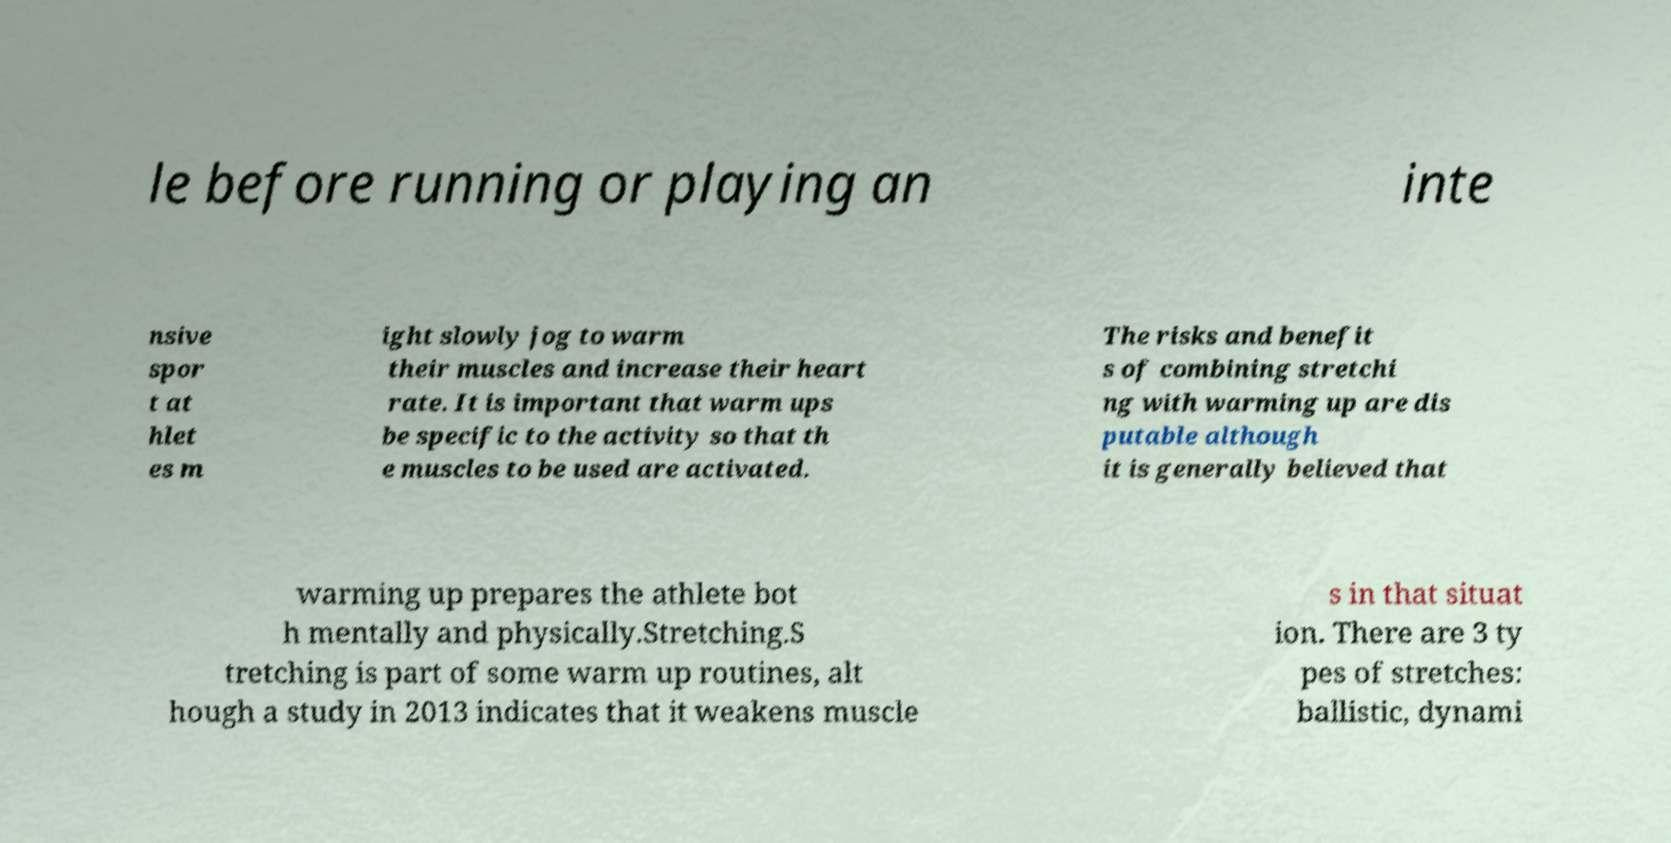I need the written content from this picture converted into text. Can you do that? le before running or playing an inte nsive spor t at hlet es m ight slowly jog to warm their muscles and increase their heart rate. It is important that warm ups be specific to the activity so that th e muscles to be used are activated. The risks and benefit s of combining stretchi ng with warming up are dis putable although it is generally believed that warming up prepares the athlete bot h mentally and physically.Stretching.S tretching is part of some warm up routines, alt hough a study in 2013 indicates that it weakens muscle s in that situat ion. There are 3 ty pes of stretches: ballistic, dynami 